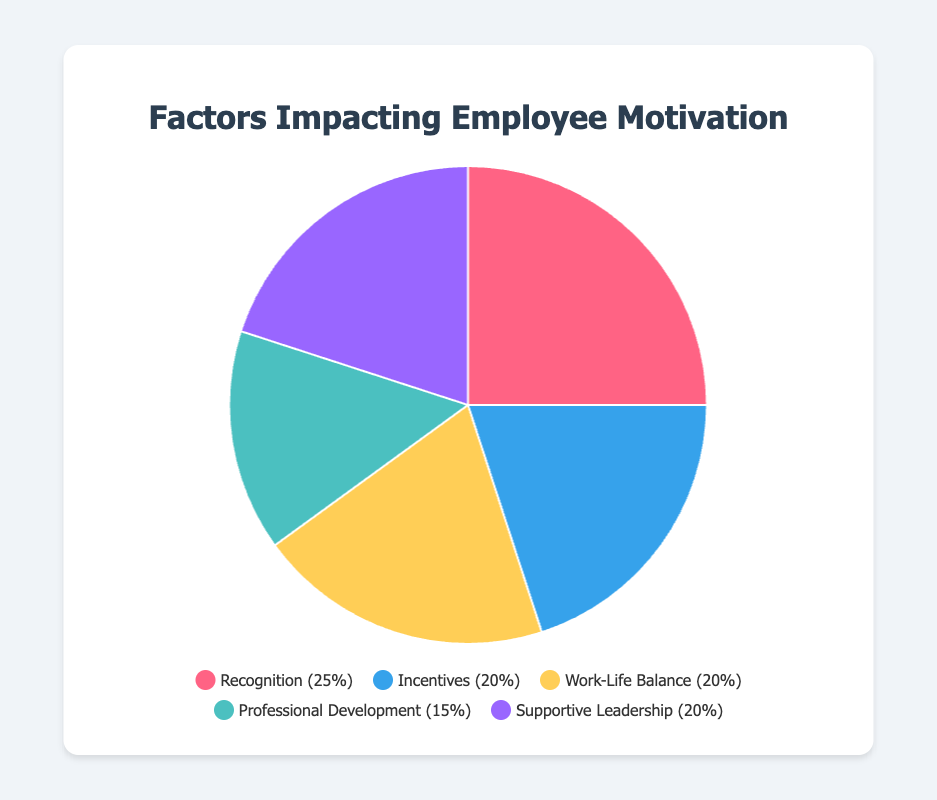What proportion of the factors contributing to employee motivation is due to Incentives and Professional Development combined? To find this, add the percentages of Incentives (20%) and Professional Development (15%). So, 20 + 15 = 35%.
Answer: 35% Which is the most significant factor impacting employee motivation and what percentage does it contribute? The most significant factor is the one with the highest percentage. From the data, Recognition has the highest value of 25%.
Answer: Recognition, 25% How do Supportive Leadership and Work-Life Balance compare in terms of their impact on employee motivation? Supportive Leadership and Work-Life Balance both contribute equally. Each of them has a percentage of 20%.
Answer: They are equal, both 20% What factor has the smallest impact on employee motivation and what percentage is it? The factor with the smallest percentage has the least impact. From the data, Professional Development has the smallest percentage of 15%.
Answer: Professional Development, 15% What is the average percentage contribution of all listed factors to employee motivation? Sum all the percentages: 25 + 20 + 20 + 15 + 20 = 100%. There are 5 factors, so the average is 100% / 5 = 20%.
Answer: 20% What is the difference in percentage between Recognition and Incentives? Subtract the percentage of Incentives (20%) from the percentage of Recognition (25%): 25 - 20 = 5%.
Answer: 5% What are the two factors that together account for 40% of employee motivation? Identify pairs of factors whose combined percentage equals 40%. Supportive Leadership (20%) and Work-Life Balance (20%) add up to 40%.
Answer: Supportive Leadership and Work-Life Balance How many factors contribute equally to employee motivation and what are they? From the data, look for factors with the same percentage. Supportive Leadership, Work-Life Balance, and Incentives each have 20%.
Answer: Three factors: Supportive Leadership, Work-Life Balance, and Incentives Which factor represented by a blue color and what percentage does it represent? The legend indicates that the blue color represents Incentives, which accounts for 20%.
Answer: Incentives, 20% 